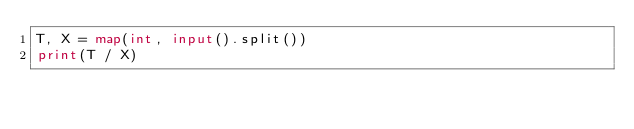<code> <loc_0><loc_0><loc_500><loc_500><_Python_>T, X = map(int, input().split())
print(T / X)</code> 